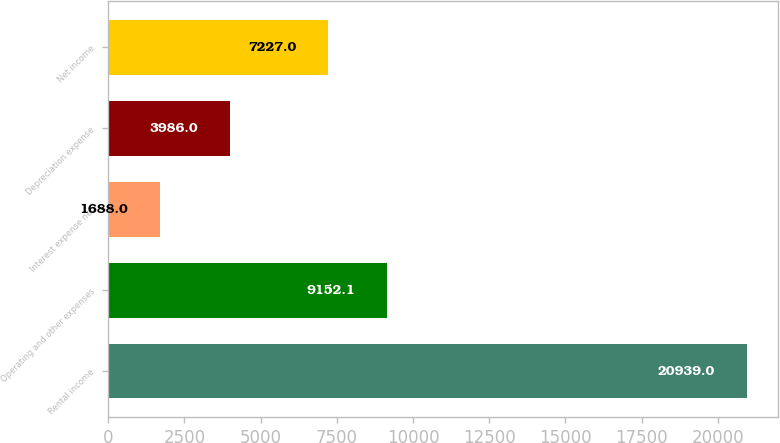Convert chart. <chart><loc_0><loc_0><loc_500><loc_500><bar_chart><fcel>Rental income<fcel>Operating and other expenses<fcel>Interest expense net<fcel>Depreciation expense<fcel>Net income<nl><fcel>20939<fcel>9152.1<fcel>1688<fcel>3986<fcel>7227<nl></chart> 